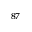<formula> <loc_0><loc_0><loc_500><loc_500>^ { 8 7 }</formula> 